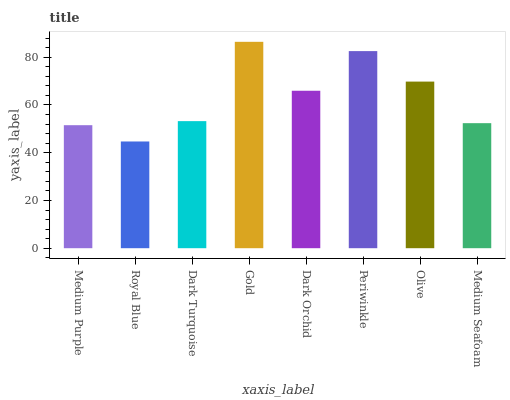Is Royal Blue the minimum?
Answer yes or no. Yes. Is Gold the maximum?
Answer yes or no. Yes. Is Dark Turquoise the minimum?
Answer yes or no. No. Is Dark Turquoise the maximum?
Answer yes or no. No. Is Dark Turquoise greater than Royal Blue?
Answer yes or no. Yes. Is Royal Blue less than Dark Turquoise?
Answer yes or no. Yes. Is Royal Blue greater than Dark Turquoise?
Answer yes or no. No. Is Dark Turquoise less than Royal Blue?
Answer yes or no. No. Is Dark Orchid the high median?
Answer yes or no. Yes. Is Dark Turquoise the low median?
Answer yes or no. Yes. Is Medium Seafoam the high median?
Answer yes or no. No. Is Gold the low median?
Answer yes or no. No. 